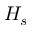<formula> <loc_0><loc_0><loc_500><loc_500>H _ { s }</formula> 